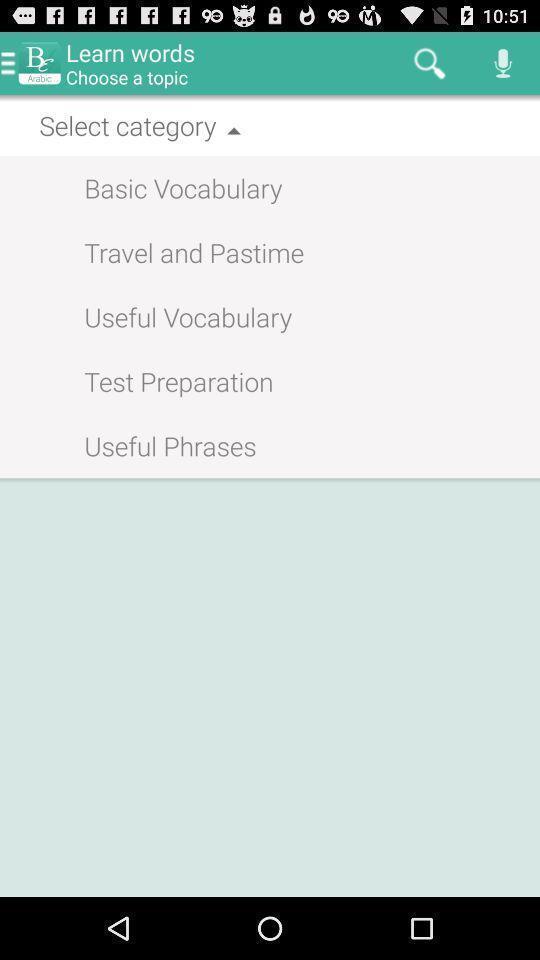Summarize the main components in this picture. Screen displaying the page with multiple categories. 